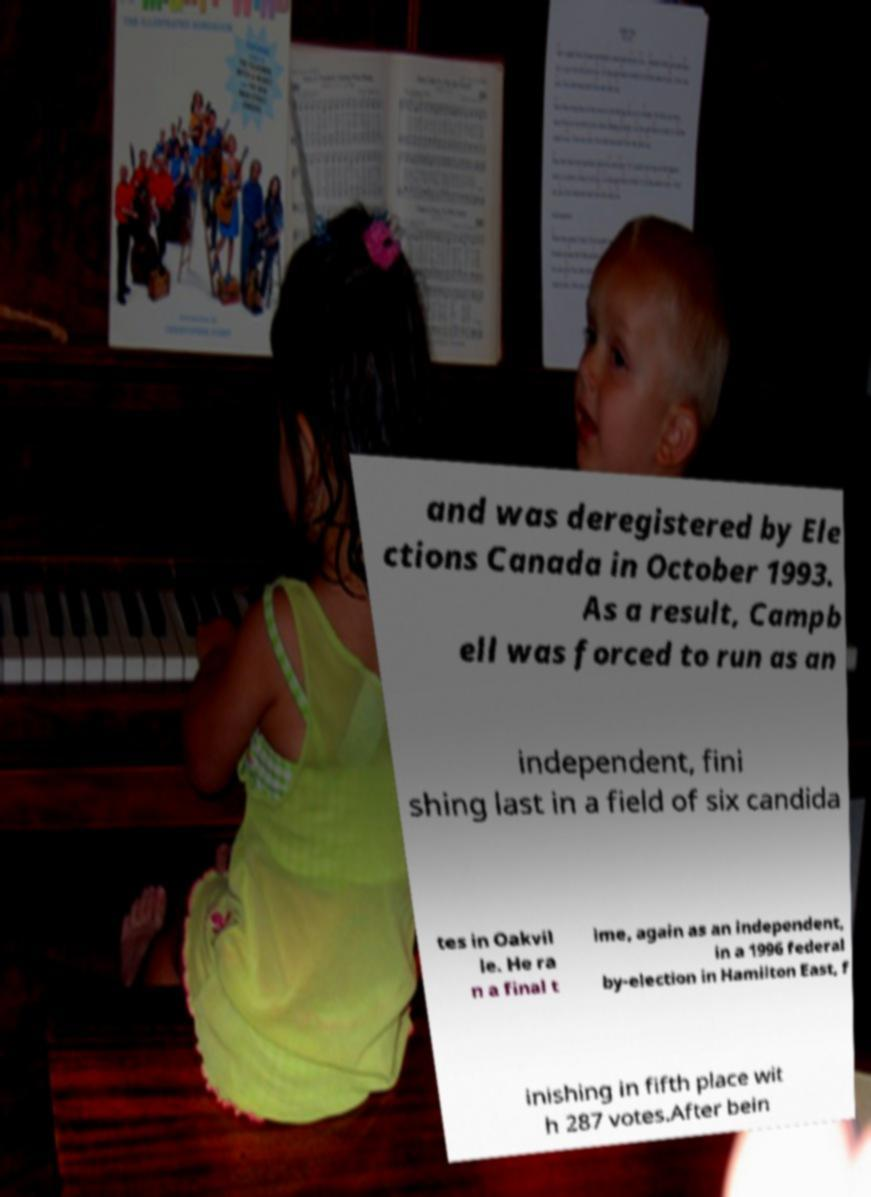Could you assist in decoding the text presented in this image and type it out clearly? and was deregistered by Ele ctions Canada in October 1993. As a result, Campb ell was forced to run as an independent, fini shing last in a field of six candida tes in Oakvil le. He ra n a final t ime, again as an independent, in a 1996 federal by-election in Hamilton East, f inishing in fifth place wit h 287 votes.After bein 